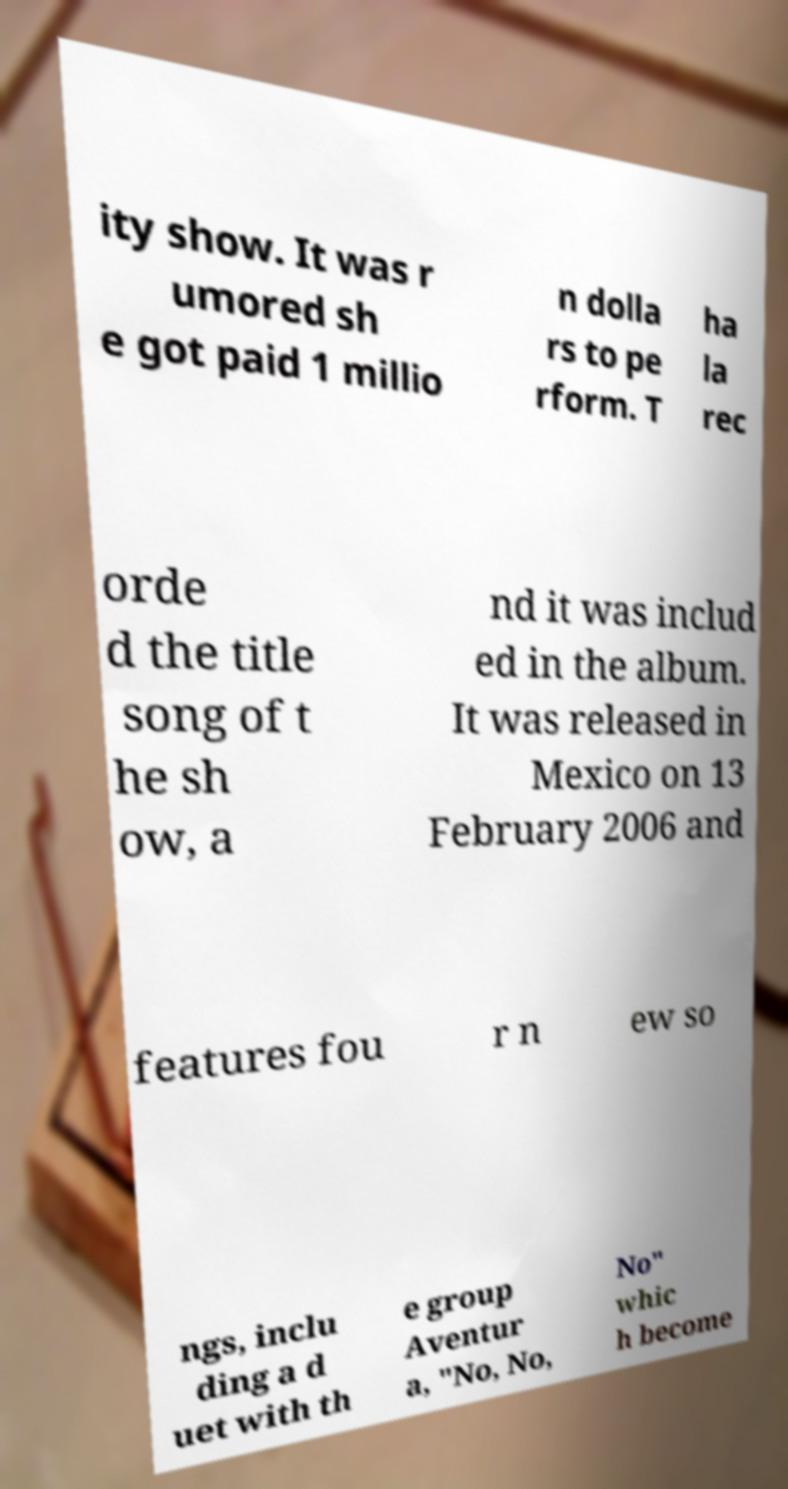I need the written content from this picture converted into text. Can you do that? ity show. It was r umored sh e got paid 1 millio n dolla rs to pe rform. T ha la rec orde d the title song of t he sh ow, a nd it was includ ed in the album. It was released in Mexico on 13 February 2006 and features fou r n ew so ngs, inclu ding a d uet with th e group Aventur a, "No, No, No" whic h become 